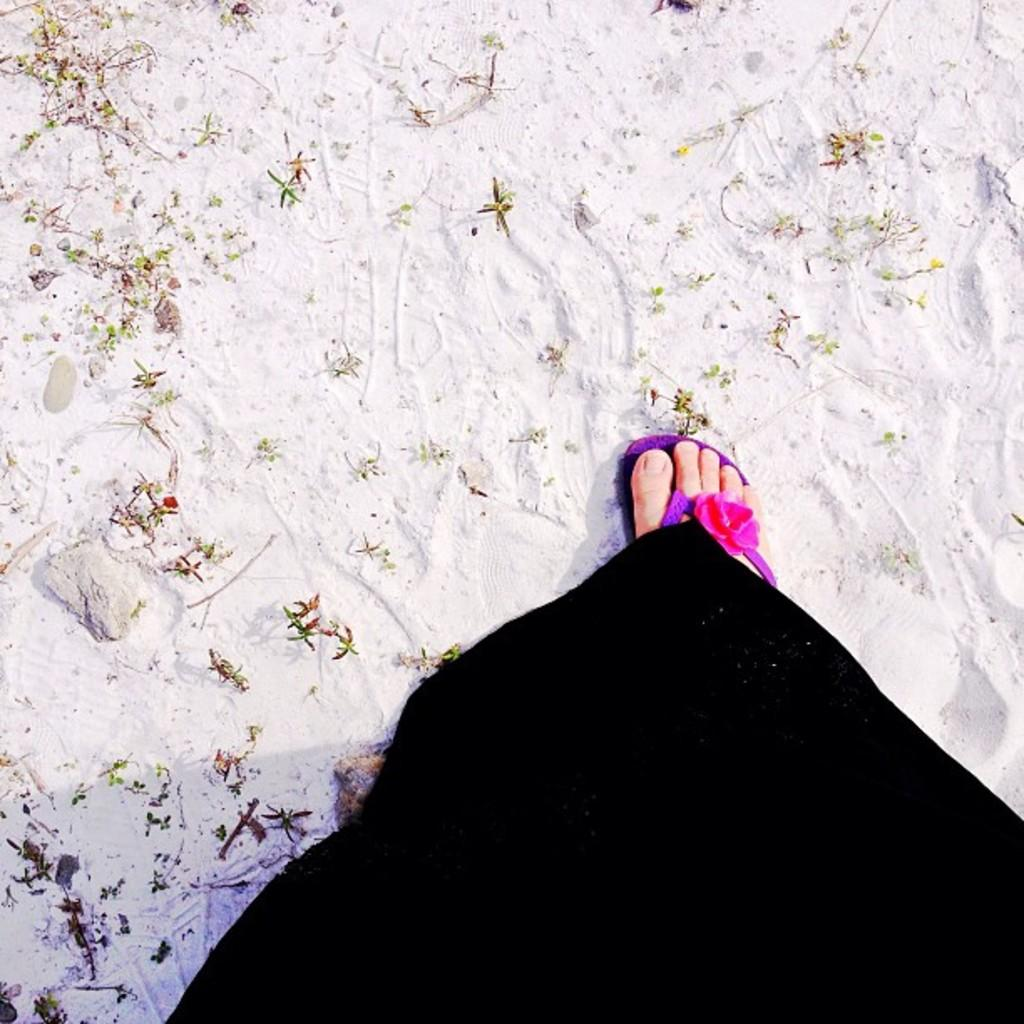What type of footwear is present in the image? There is footwear in the image. Can you describe the foot that is visible in the image? A foot of a person is visible in the image. What else can be seen on the ground in the image? There are a few things on the ground in the image. What type of education can be seen being taught in the image? There is no indication of education or teaching in the image. Is there any writing visible on the footwear in the image? The facts do not mention any writing on the footwear, so we cannot determine if there is any writing visible. 